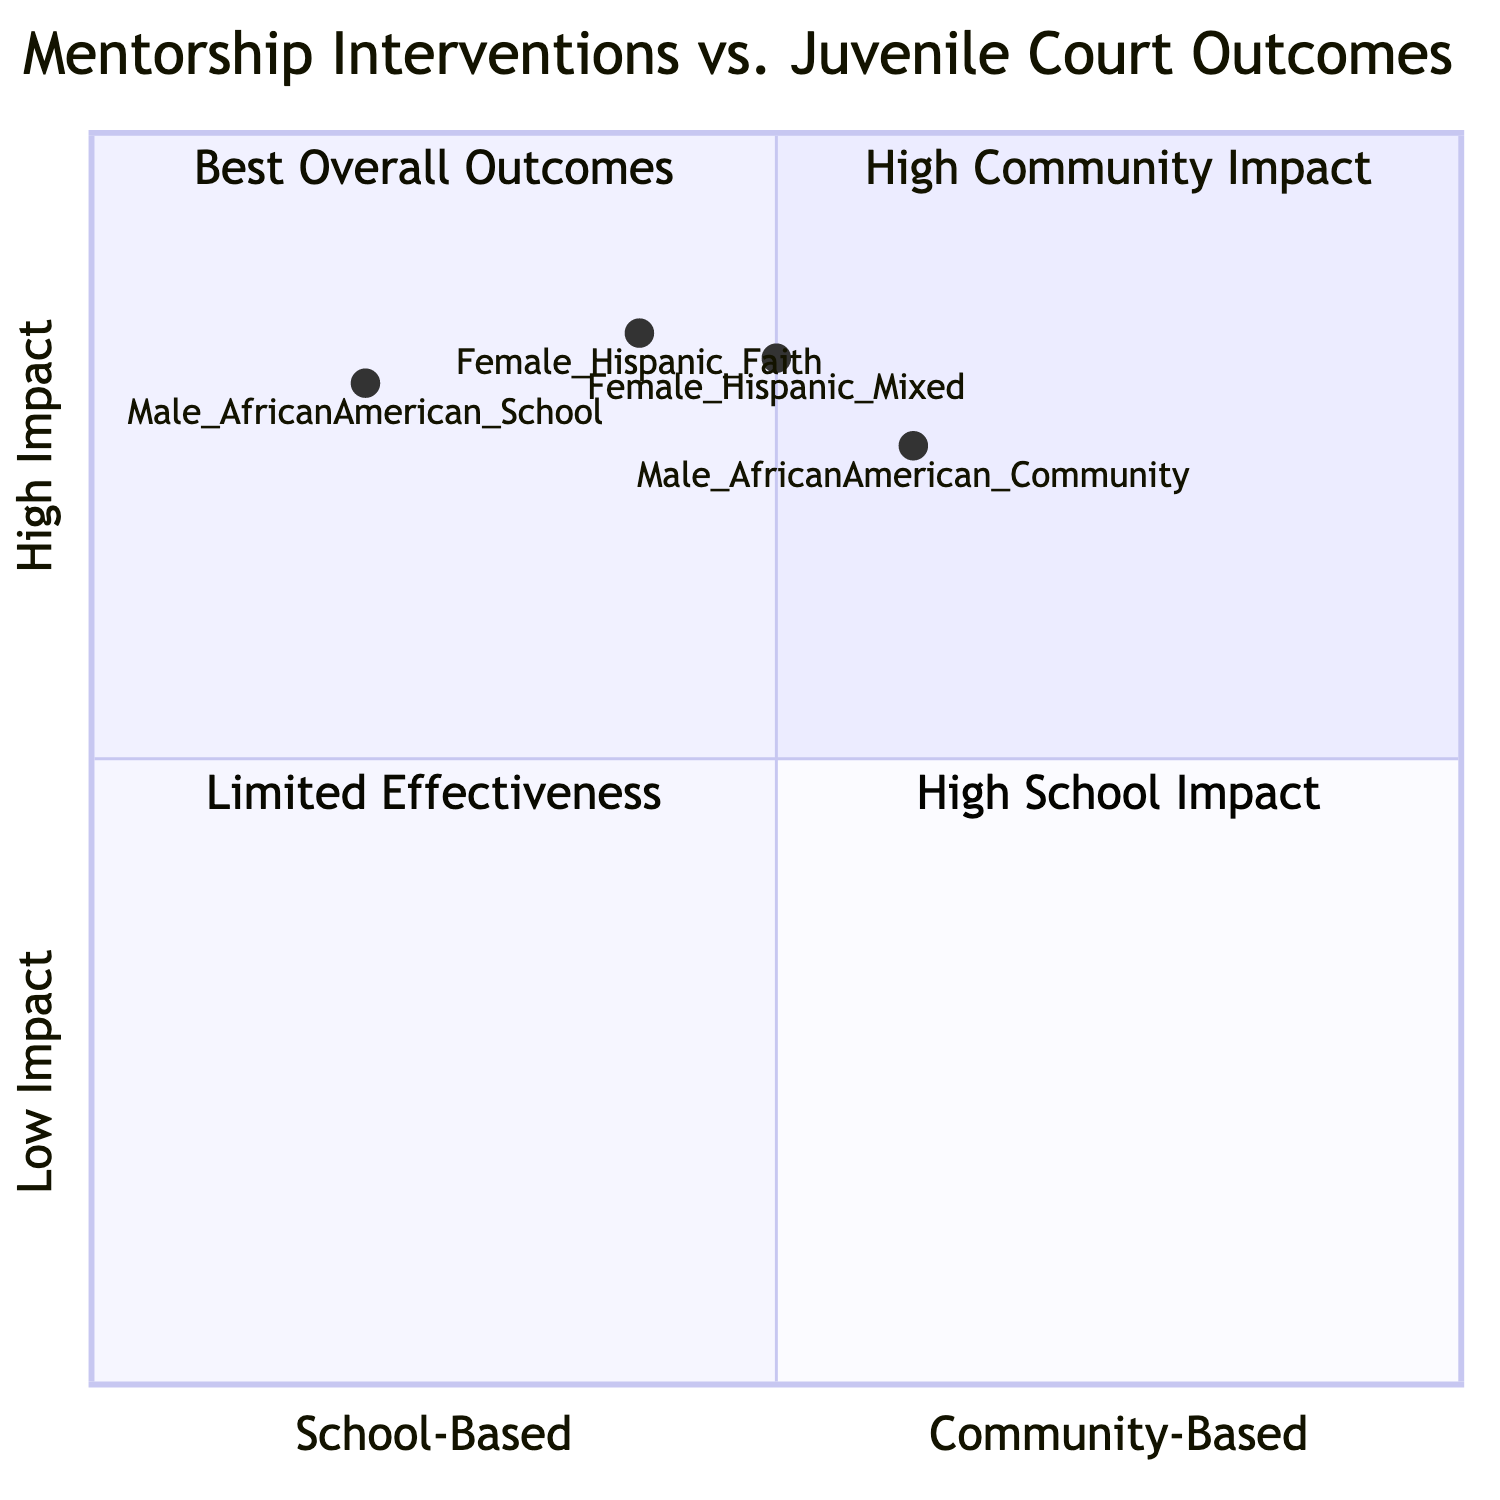What are the recidivism rates for Male African American students in School-Based mentorship programs? The diagram indicates that the recidivism rate for Male African American students in School-Based mentorship is 20%.
Answer: 20% Which mentorship intervention has the highest probation compliance for Female Hispanic students? The diagram shows that the Faith-Based mentorship program has a probation compliance of 85%, which is higher than the Mixed-Approach's 82%.
Answer: Faith-Based In which quadrant is the Community-Based Mentorship program for Male African American students located? The data point for Male African American students under Community-Based Mentorship has a recidivism rate of 25% and probation compliance of 75%, placing it in Quadrant 3: Limited Effectiveness.
Answer: Quadrant 3 What is the percentage of school attendance for Female Hispanic students in the Faith-Based mentorship program? According to the diagram, Female Hispanic students in the Faith-Based mentorship program have a school attendance rate of 92%.
Answer: 92% Is the school attendance higher for Male African American students in School-Based or Community-Based mentorship programs? Male African American students have a school attendance rate of 90% in School-Based mentorship versus 85% in Community-Based mentorship, indicating higher attendance in School-Based.
Answer: School-Based What does Quadrant 1 represent based on the placement of the data points? Quadrant 1 indicates High Community Impact, which is evidenced by the successful outcomes of the relevant mentorship programs.
Answer: High Community Impact Which group has better behavioral improvements: Male African American students in School-Based or Female Hispanic students in Mixed-Approach mentorship? Male African American students show behavioral improvements at 70% in School-Based mentorship, while Female Hispanic students show 70% in Mixed-Approach mentorship, indicating equal outcomes.
Answer: Equal How many data points are based on Male participants in the diagram? The diagram identifies two data points derived from Male participants (Male African American under School-Based and Community-Based mentorship).
Answer: 2 What is the probation compliance percentage for Male African American students in Community-Based mentorship? The diagram specifies that the probation compliance for Male African American students in Community-Based mentorship is 75%.
Answer: 75% 